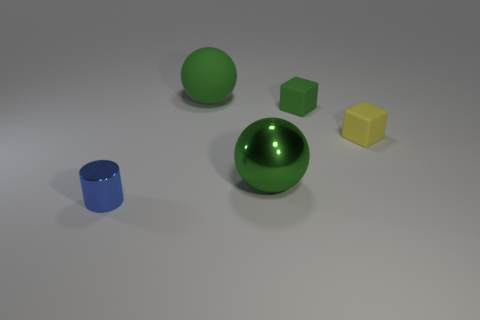Compare the two spheres in the image—how are they different? The two spheres differ in size, color, and finish. The larger sphere has a green, glossy surface while the smaller sphere is less reflective and matte, colored in a solid, uniform lighter green. 